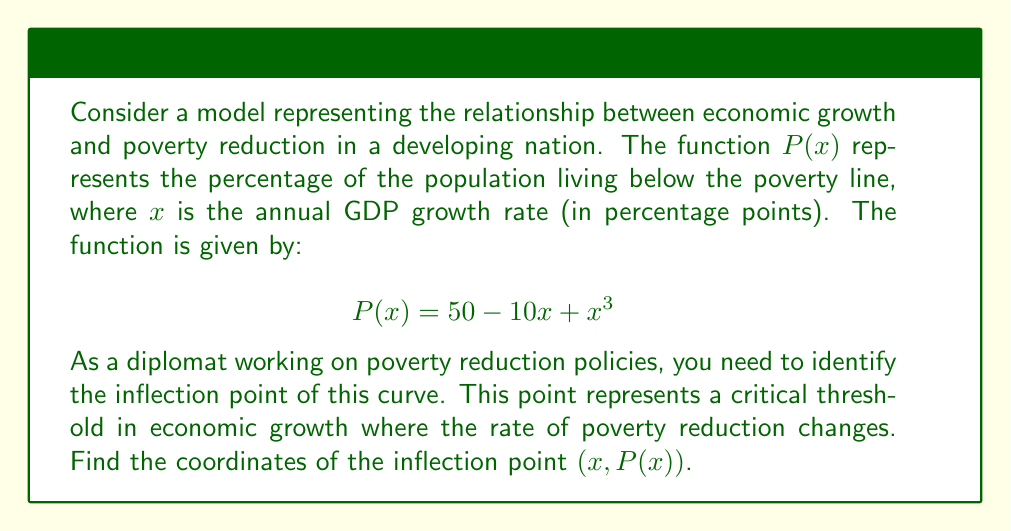Teach me how to tackle this problem. To find the inflection point, we need to follow these steps:

1) The inflection point occurs where the second derivative of the function changes sign. We first need to find the first and second derivatives of $P(x)$.

2) First derivative: 
   $$P'(x) = -10 + 3x^2$$

3) Second derivative:
   $$P''(x) = 6x$$

4) The inflection point occurs where $P''(x) = 0$:
   $$6x = 0$$
   $$x = 0$$

5) To find the y-coordinate, we substitute $x = 0$ into the original function:
   $$P(0) = 50 - 10(0) + 0^3 = 50$$

6) Therefore, the inflection point is at (0, 50).

7) To interpret this result:
   - When the GDP growth rate is 0%, 50% of the population is below the poverty line.
   - This point represents a transition in the effectiveness of economic growth on poverty reduction.
   - For growth rates below 0%, poverty reduction accelerates as growth increases.
   - For growth rates above 0%, the rate of poverty reduction starts to slow down as growth increases.

This information is crucial for a diplomat developing policies to address poverty, as it highlights the importance of achieving positive economic growth and the changing dynamics of growth's impact on poverty reduction.
Answer: (0, 50) 